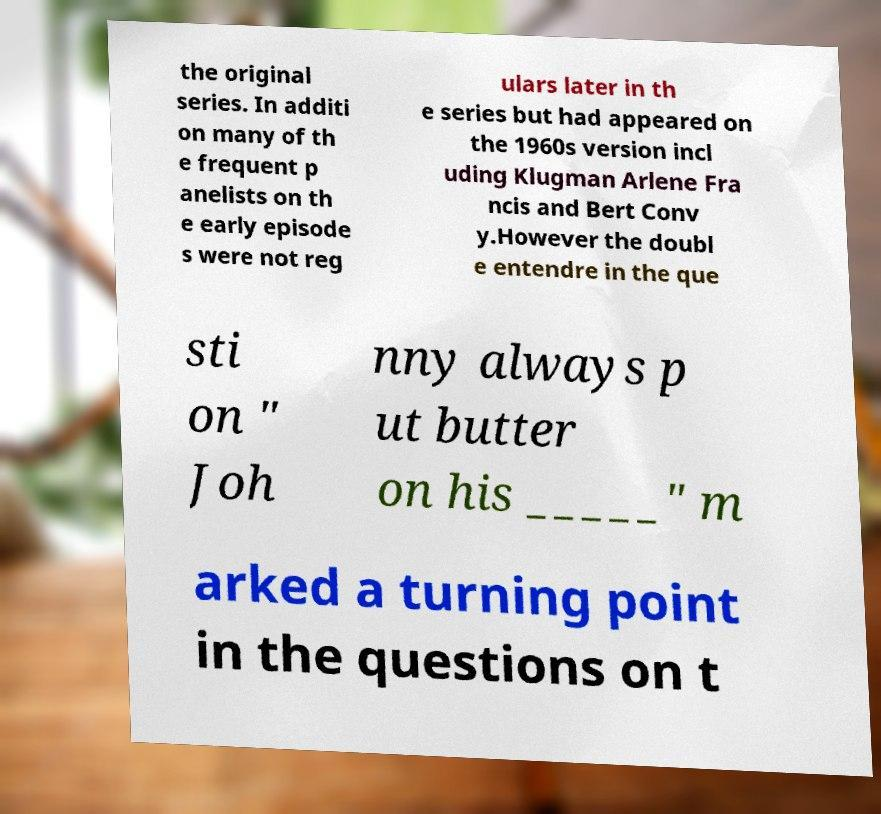I need the written content from this picture converted into text. Can you do that? the original series. In additi on many of th e frequent p anelists on th e early episode s were not reg ulars later in th e series but had appeared on the 1960s version incl uding Klugman Arlene Fra ncis and Bert Conv y.However the doubl e entendre in the que sti on " Joh nny always p ut butter on his _____" m arked a turning point in the questions on t 